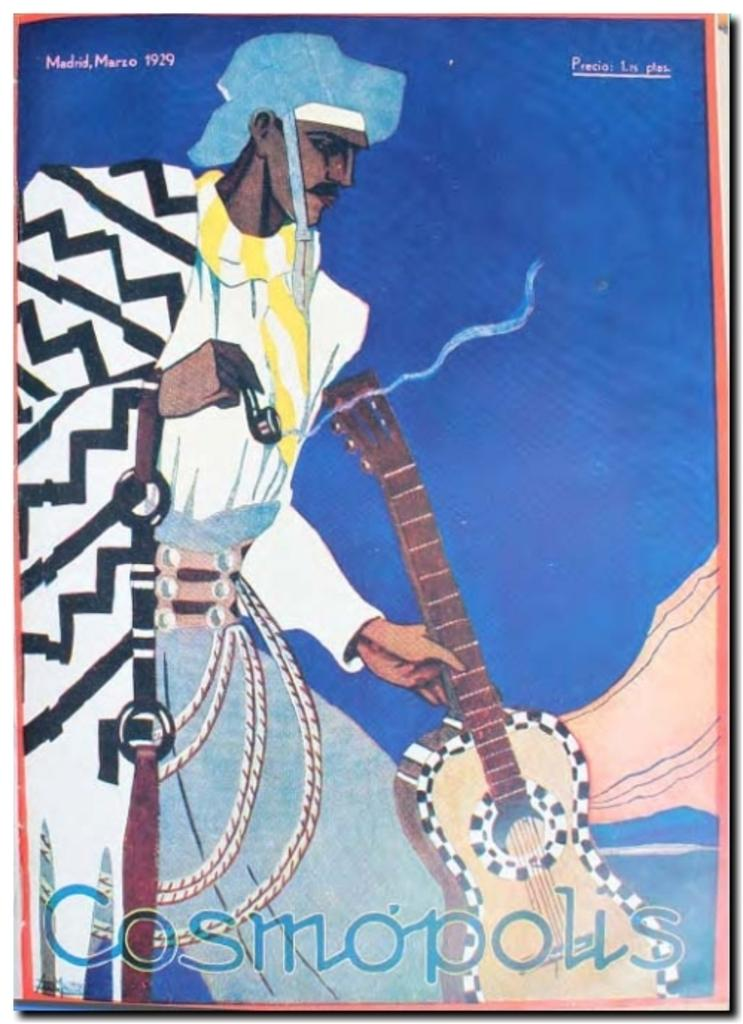What is the main subject of the image? There is a painting in the image. What is the painting depicting? The painting depicts a person standing. What is the person in the painting holding? The person in the painting is holding a musical instrument. What type of fowl can be seen in the painting? There is no fowl present in the painting; it depicts a person holding a musical instrument. What kind of jewel is the person wearing in the painting? There is no information about any jewels worn by the person in the painting. 